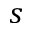Convert formula to latex. <formula><loc_0><loc_0><loc_500><loc_500>s</formula> 